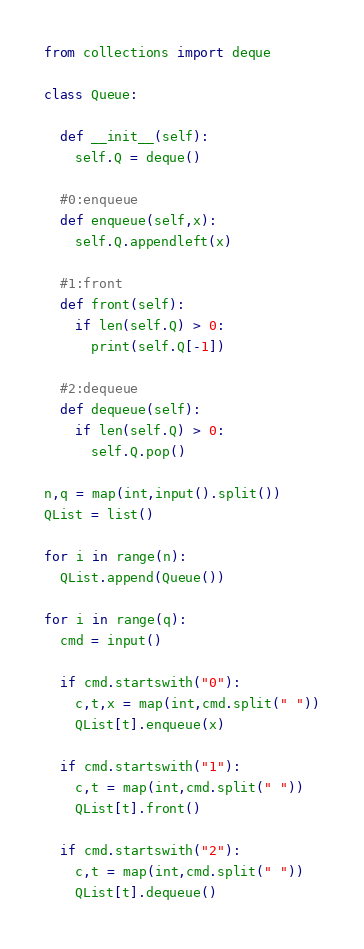Convert code to text. <code><loc_0><loc_0><loc_500><loc_500><_Python_>from collections import deque

class Queue:

  def __init__(self):
    self.Q = deque()

  #0:enqueue
  def enqueue(self,x):
    self.Q.appendleft(x)

  #1:front
  def front(self):
    if len(self.Q) > 0:
      print(self.Q[-1])
      
  #2:dequeue
  def dequeue(self):
    if len(self.Q) > 0:
      self.Q.pop()

n,q = map(int,input().split())
QList = list()

for i in range(n):
  QList.append(Queue())

for i in range(q):
  cmd = input()
  
  if cmd.startswith("0"):
    c,t,x = map(int,cmd.split(" "))
    QList[t].enqueue(x)
    
  if cmd.startswith("1"):
    c,t = map(int,cmd.split(" "))
    QList[t].front()
  
  if cmd.startswith("2"):
    c,t = map(int,cmd.split(" "))
    QList[t].dequeue()

</code> 